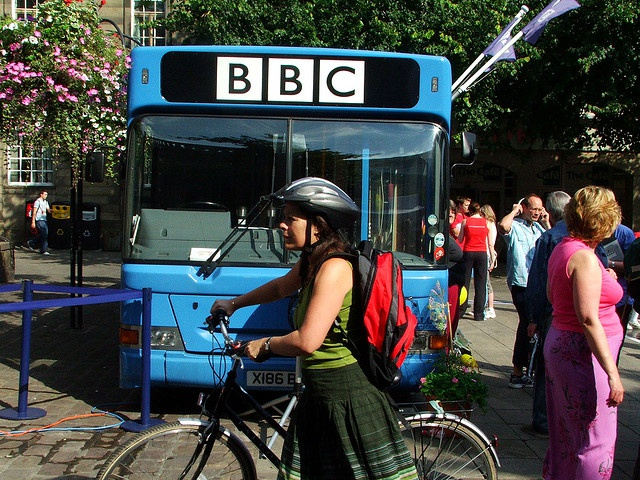Describe the objects in this image and their specific colors. I can see bus in gray, black, lightblue, teal, and white tones, people in gray, black, tan, and darkgreen tones, bicycle in gray and black tones, people in gray, black, maroon, violet, and lightpink tones, and backpack in gray, black, red, and salmon tones in this image. 